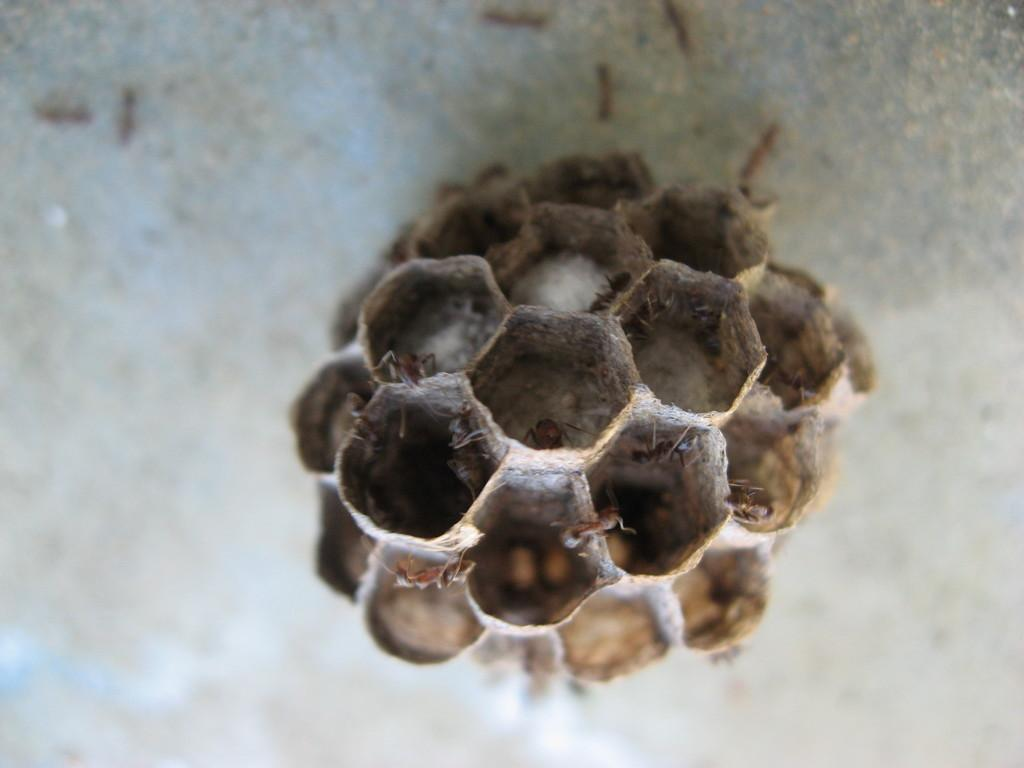What is present on the honeycomb in the image? There are insects on the honeycomb. Are there any other insects visible in the image? Yes, there are additional insects visible in the image. Can you describe the background of the image? The background of the image is blurred. What type of haircut is the insect getting in the image? There is no haircut being given to any insect in the image. 